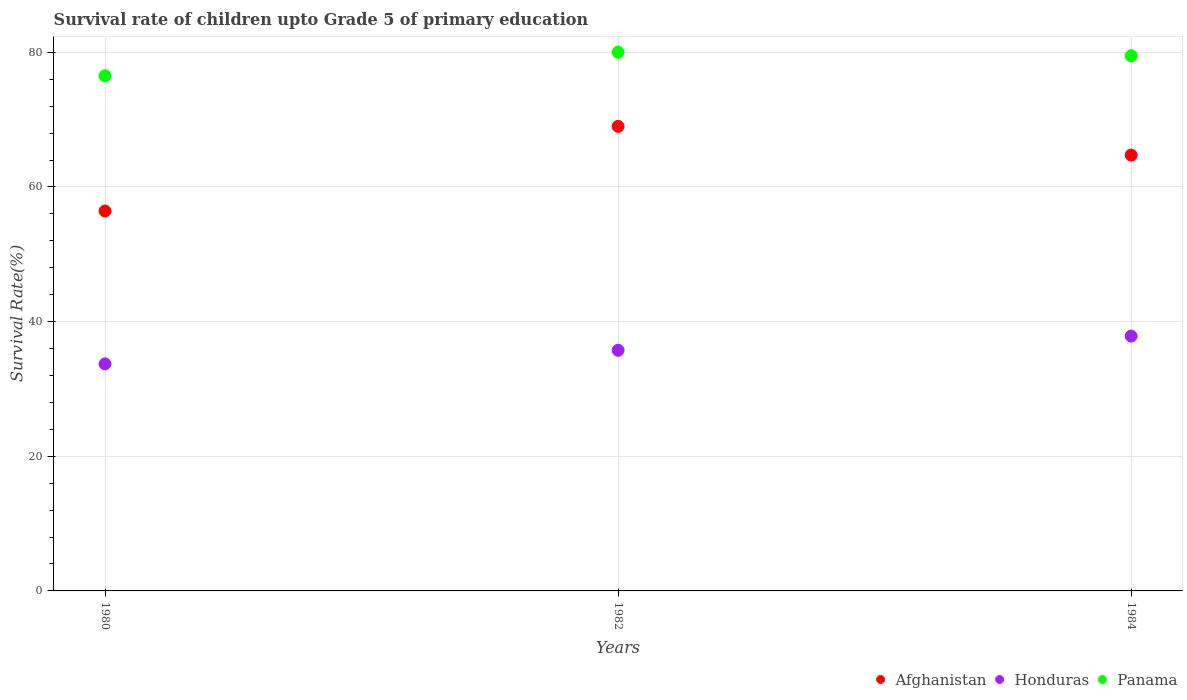Is the number of dotlines equal to the number of legend labels?
Offer a very short reply. Yes. What is the survival rate of children in Afghanistan in 1982?
Your answer should be very brief. 69. Across all years, what is the maximum survival rate of children in Afghanistan?
Your answer should be compact. 69. Across all years, what is the minimum survival rate of children in Afghanistan?
Ensure brevity in your answer.  56.43. What is the total survival rate of children in Afghanistan in the graph?
Your answer should be very brief. 190.16. What is the difference between the survival rate of children in Panama in 1980 and that in 1984?
Give a very brief answer. -2.98. What is the difference between the survival rate of children in Panama in 1980 and the survival rate of children in Afghanistan in 1982?
Keep it short and to the point. 7.52. What is the average survival rate of children in Afghanistan per year?
Ensure brevity in your answer.  63.39. In the year 1980, what is the difference between the survival rate of children in Honduras and survival rate of children in Afghanistan?
Your answer should be compact. -22.7. What is the ratio of the survival rate of children in Panama in 1982 to that in 1984?
Your answer should be very brief. 1.01. What is the difference between the highest and the second highest survival rate of children in Honduras?
Your answer should be compact. 2.11. What is the difference between the highest and the lowest survival rate of children in Afghanistan?
Your answer should be very brief. 12.58. Is it the case that in every year, the sum of the survival rate of children in Honduras and survival rate of children in Panama  is greater than the survival rate of children in Afghanistan?
Offer a terse response. Yes. Is the survival rate of children in Afghanistan strictly greater than the survival rate of children in Honduras over the years?
Provide a short and direct response. Yes. How many dotlines are there?
Make the answer very short. 3. What is the difference between two consecutive major ticks on the Y-axis?
Ensure brevity in your answer.  20. Does the graph contain any zero values?
Ensure brevity in your answer.  No. How many legend labels are there?
Keep it short and to the point. 3. How are the legend labels stacked?
Ensure brevity in your answer.  Horizontal. What is the title of the graph?
Your response must be concise. Survival rate of children upto Grade 5 of primary education. Does "Trinidad and Tobago" appear as one of the legend labels in the graph?
Offer a terse response. No. What is the label or title of the Y-axis?
Your answer should be very brief. Survival Rate(%). What is the Survival Rate(%) in Afghanistan in 1980?
Make the answer very short. 56.43. What is the Survival Rate(%) of Honduras in 1980?
Provide a succinct answer. 33.73. What is the Survival Rate(%) of Panama in 1980?
Your answer should be very brief. 76.52. What is the Survival Rate(%) of Afghanistan in 1982?
Your answer should be very brief. 69. What is the Survival Rate(%) of Honduras in 1982?
Your answer should be very brief. 35.74. What is the Survival Rate(%) of Panama in 1982?
Give a very brief answer. 80.03. What is the Survival Rate(%) in Afghanistan in 1984?
Your answer should be compact. 64.73. What is the Survival Rate(%) of Honduras in 1984?
Give a very brief answer. 37.85. What is the Survival Rate(%) in Panama in 1984?
Give a very brief answer. 79.5. Across all years, what is the maximum Survival Rate(%) of Afghanistan?
Your answer should be very brief. 69. Across all years, what is the maximum Survival Rate(%) of Honduras?
Give a very brief answer. 37.85. Across all years, what is the maximum Survival Rate(%) of Panama?
Your answer should be very brief. 80.03. Across all years, what is the minimum Survival Rate(%) in Afghanistan?
Keep it short and to the point. 56.43. Across all years, what is the minimum Survival Rate(%) in Honduras?
Your response must be concise. 33.73. Across all years, what is the minimum Survival Rate(%) in Panama?
Your answer should be very brief. 76.52. What is the total Survival Rate(%) of Afghanistan in the graph?
Your response must be concise. 190.16. What is the total Survival Rate(%) in Honduras in the graph?
Offer a very short reply. 107.32. What is the total Survival Rate(%) of Panama in the graph?
Your answer should be very brief. 236.05. What is the difference between the Survival Rate(%) of Afghanistan in 1980 and that in 1982?
Offer a terse response. -12.58. What is the difference between the Survival Rate(%) of Honduras in 1980 and that in 1982?
Offer a very short reply. -2.02. What is the difference between the Survival Rate(%) of Panama in 1980 and that in 1982?
Provide a succinct answer. -3.51. What is the difference between the Survival Rate(%) in Afghanistan in 1980 and that in 1984?
Provide a short and direct response. -8.3. What is the difference between the Survival Rate(%) of Honduras in 1980 and that in 1984?
Offer a very short reply. -4.12. What is the difference between the Survival Rate(%) in Panama in 1980 and that in 1984?
Your answer should be very brief. -2.98. What is the difference between the Survival Rate(%) of Afghanistan in 1982 and that in 1984?
Offer a terse response. 4.27. What is the difference between the Survival Rate(%) of Honduras in 1982 and that in 1984?
Provide a succinct answer. -2.11. What is the difference between the Survival Rate(%) in Panama in 1982 and that in 1984?
Provide a short and direct response. 0.53. What is the difference between the Survival Rate(%) of Afghanistan in 1980 and the Survival Rate(%) of Honduras in 1982?
Make the answer very short. 20.68. What is the difference between the Survival Rate(%) in Afghanistan in 1980 and the Survival Rate(%) in Panama in 1982?
Ensure brevity in your answer.  -23.6. What is the difference between the Survival Rate(%) in Honduras in 1980 and the Survival Rate(%) in Panama in 1982?
Give a very brief answer. -46.3. What is the difference between the Survival Rate(%) in Afghanistan in 1980 and the Survival Rate(%) in Honduras in 1984?
Give a very brief answer. 18.58. What is the difference between the Survival Rate(%) of Afghanistan in 1980 and the Survival Rate(%) of Panama in 1984?
Offer a terse response. -23.07. What is the difference between the Survival Rate(%) in Honduras in 1980 and the Survival Rate(%) in Panama in 1984?
Give a very brief answer. -45.77. What is the difference between the Survival Rate(%) of Afghanistan in 1982 and the Survival Rate(%) of Honduras in 1984?
Make the answer very short. 31.15. What is the difference between the Survival Rate(%) of Afghanistan in 1982 and the Survival Rate(%) of Panama in 1984?
Provide a succinct answer. -10.49. What is the difference between the Survival Rate(%) of Honduras in 1982 and the Survival Rate(%) of Panama in 1984?
Provide a succinct answer. -43.76. What is the average Survival Rate(%) in Afghanistan per year?
Your answer should be very brief. 63.39. What is the average Survival Rate(%) of Honduras per year?
Offer a terse response. 35.77. What is the average Survival Rate(%) of Panama per year?
Ensure brevity in your answer.  78.68. In the year 1980, what is the difference between the Survival Rate(%) in Afghanistan and Survival Rate(%) in Honduras?
Make the answer very short. 22.7. In the year 1980, what is the difference between the Survival Rate(%) of Afghanistan and Survival Rate(%) of Panama?
Your answer should be very brief. -20.09. In the year 1980, what is the difference between the Survival Rate(%) of Honduras and Survival Rate(%) of Panama?
Offer a very short reply. -42.79. In the year 1982, what is the difference between the Survival Rate(%) of Afghanistan and Survival Rate(%) of Honduras?
Your answer should be compact. 33.26. In the year 1982, what is the difference between the Survival Rate(%) in Afghanistan and Survival Rate(%) in Panama?
Ensure brevity in your answer.  -11.02. In the year 1982, what is the difference between the Survival Rate(%) of Honduras and Survival Rate(%) of Panama?
Make the answer very short. -44.29. In the year 1984, what is the difference between the Survival Rate(%) of Afghanistan and Survival Rate(%) of Honduras?
Your response must be concise. 26.88. In the year 1984, what is the difference between the Survival Rate(%) in Afghanistan and Survival Rate(%) in Panama?
Your response must be concise. -14.77. In the year 1984, what is the difference between the Survival Rate(%) in Honduras and Survival Rate(%) in Panama?
Give a very brief answer. -41.65. What is the ratio of the Survival Rate(%) of Afghanistan in 1980 to that in 1982?
Your response must be concise. 0.82. What is the ratio of the Survival Rate(%) of Honduras in 1980 to that in 1982?
Keep it short and to the point. 0.94. What is the ratio of the Survival Rate(%) of Panama in 1980 to that in 1982?
Ensure brevity in your answer.  0.96. What is the ratio of the Survival Rate(%) of Afghanistan in 1980 to that in 1984?
Keep it short and to the point. 0.87. What is the ratio of the Survival Rate(%) of Honduras in 1980 to that in 1984?
Keep it short and to the point. 0.89. What is the ratio of the Survival Rate(%) in Panama in 1980 to that in 1984?
Provide a short and direct response. 0.96. What is the ratio of the Survival Rate(%) of Afghanistan in 1982 to that in 1984?
Your answer should be very brief. 1.07. What is the ratio of the Survival Rate(%) in Honduras in 1982 to that in 1984?
Your response must be concise. 0.94. What is the difference between the highest and the second highest Survival Rate(%) of Afghanistan?
Your response must be concise. 4.27. What is the difference between the highest and the second highest Survival Rate(%) of Honduras?
Your answer should be very brief. 2.11. What is the difference between the highest and the second highest Survival Rate(%) in Panama?
Provide a succinct answer. 0.53. What is the difference between the highest and the lowest Survival Rate(%) in Afghanistan?
Keep it short and to the point. 12.58. What is the difference between the highest and the lowest Survival Rate(%) of Honduras?
Give a very brief answer. 4.12. What is the difference between the highest and the lowest Survival Rate(%) in Panama?
Give a very brief answer. 3.51. 